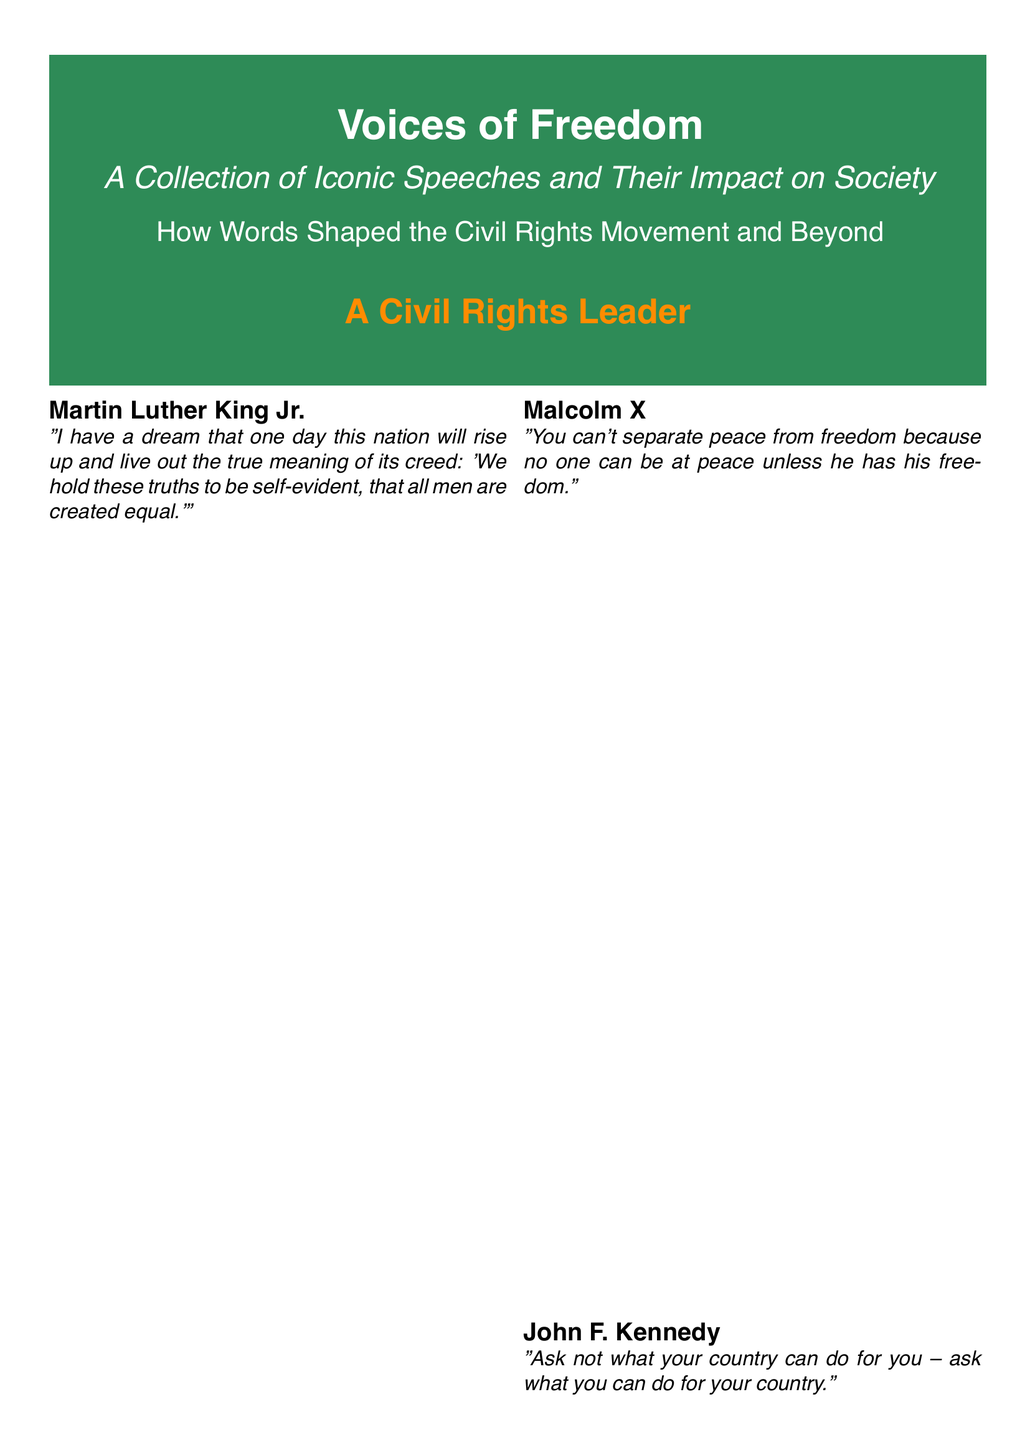What is the title of the book? The title of the book is prominently displayed on the cover.
Answer: Voices of Freedom Who is the publisher of the book? The document mentions the publishing company in a designated area.
Answer: Freedom Press What is the ISBN number? The ISBN number is listed in the publication information section.
Answer: 978-3-16-148410-0 Which speech is associated with Martin Luther King Jr.? The document lists key speeches linked to various figures.
Answer: I Have a Dream Who delivered the quote about the Constitution? The document attributes a specific quote to a notable individual.
Answer: Barbara Jordan What is a central theme of the book's analysis? The description highlights the core focus of the book's content.
Answer: Impact on society How many iconic speeches are highlighted in the contents? The number of speeches listed provides this information.
Answer: Four What format does the book primarily focus on? The focus is indicated by the title and content described.
Answer: Speeches Which speech is titled "The Ballot or the Bullet"? The document associates specific speeches with their respective speakers.
Answer: Malcolm X 